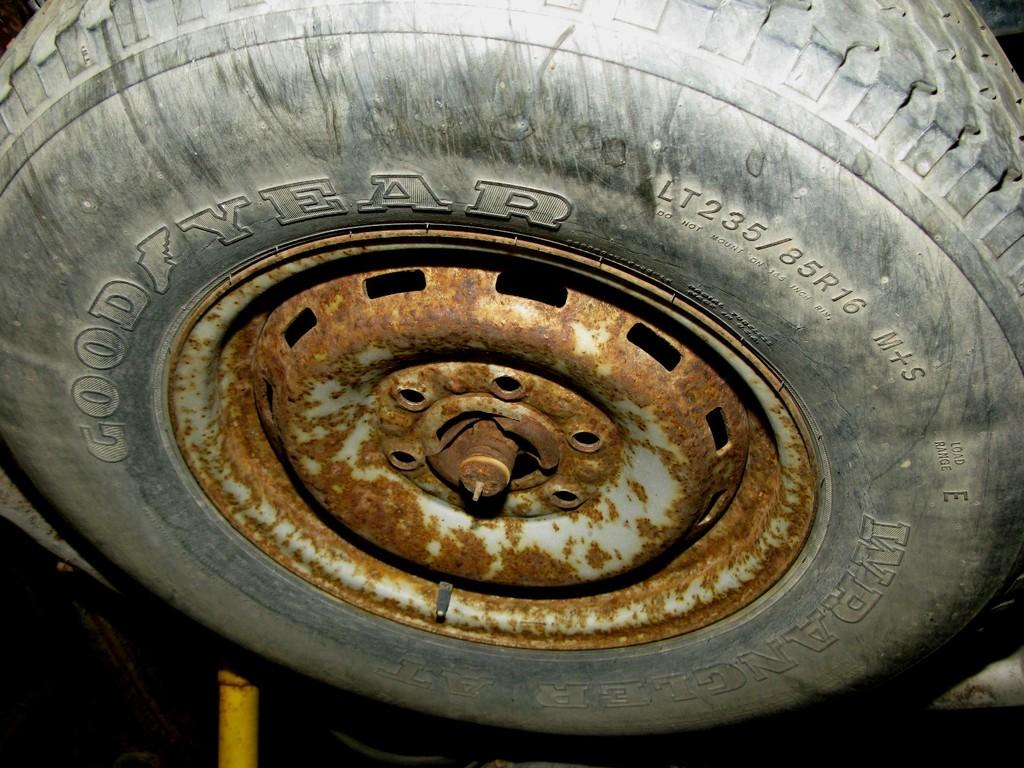What is the main object in the center of the image? There is a tyre in the center of the image. What is written or printed on the tyre? There is text on the tyre. What other object can be seen at the bottom of the image? There is a yellow color pole at the bottom of the image. How would you describe the overall lighting or brightness in the image? The background of the image is dark. What type of drum can be heard playing in the background of the image? There is no drum or sound present in the image; it is a still image featuring a tyre, text, and a yellow pole. 